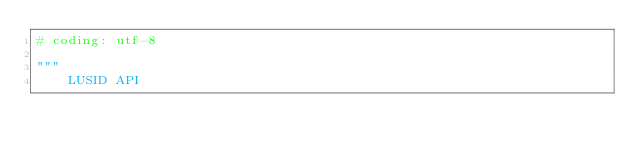Convert code to text. <code><loc_0><loc_0><loc_500><loc_500><_Python_># coding: utf-8

"""
    LUSID API
</code> 